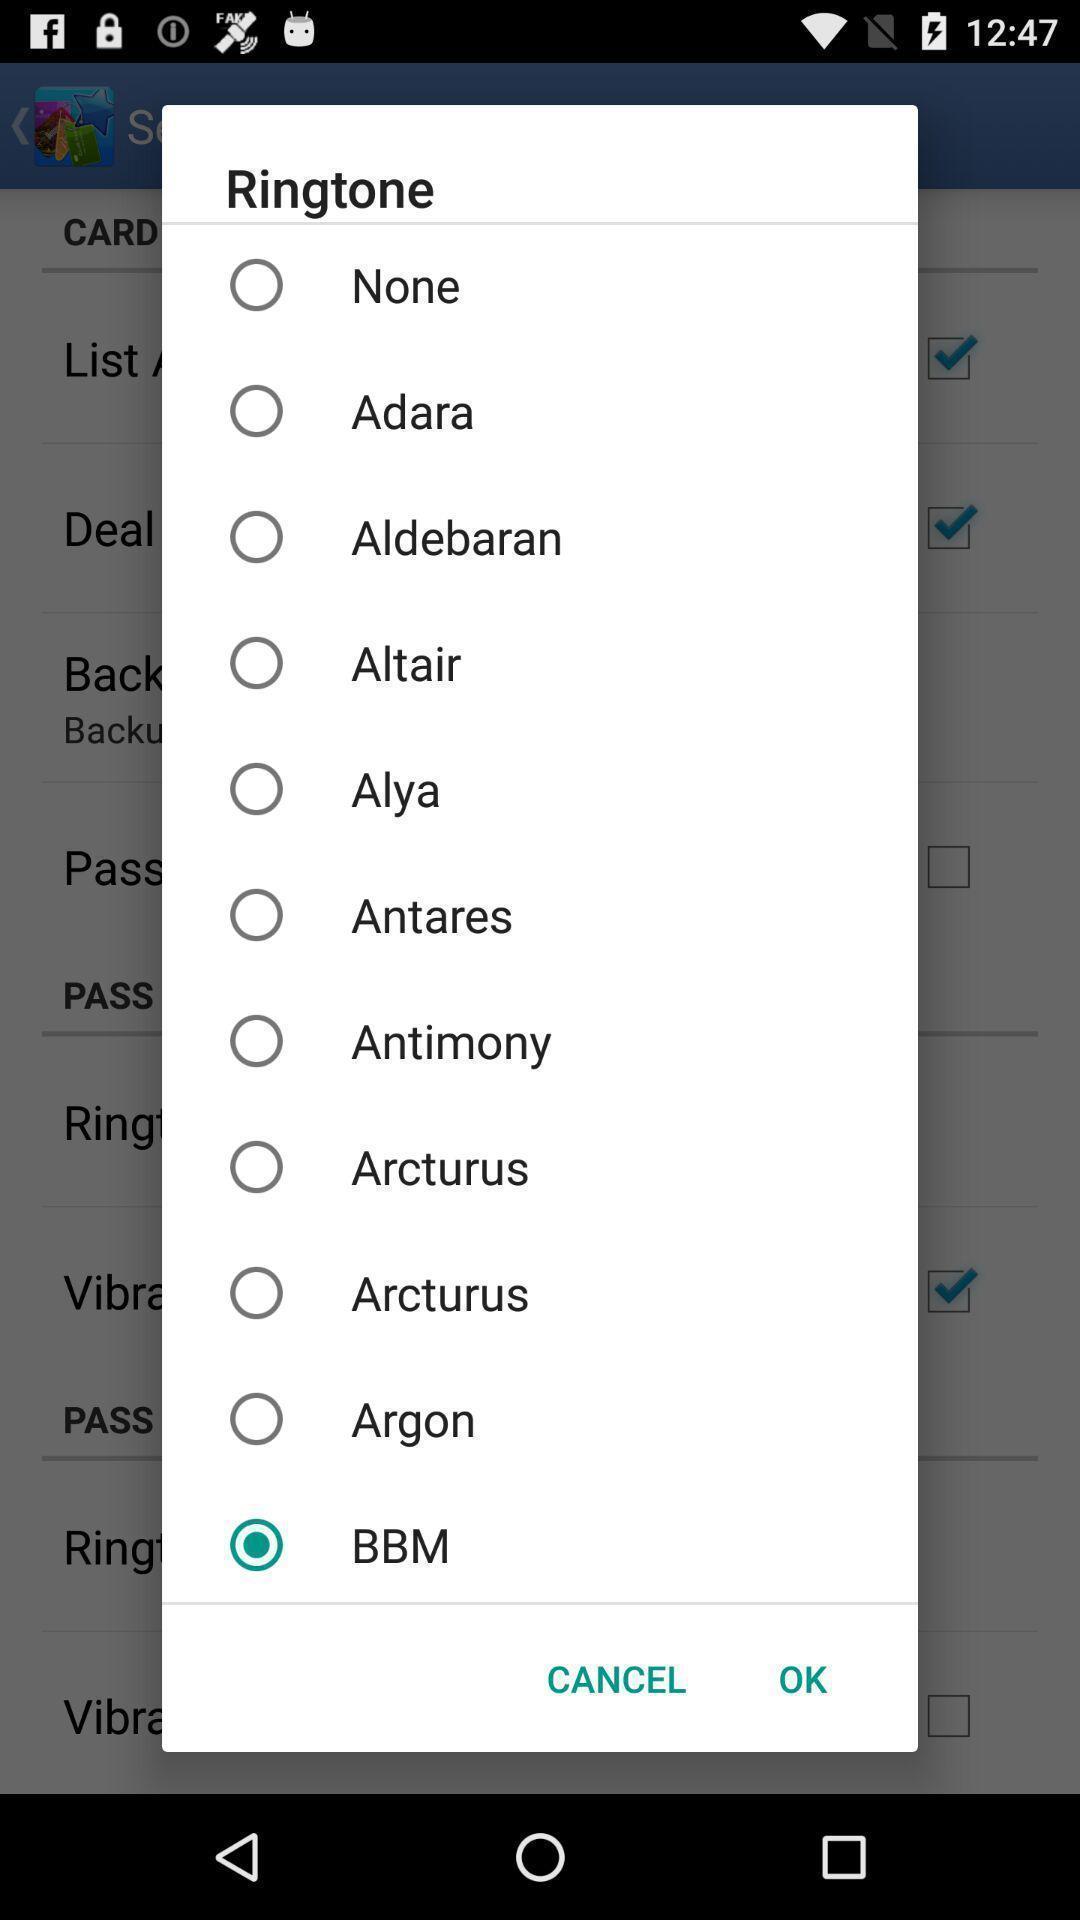Summarize the information in this screenshot. Pop-up showing list of various ringtones. 